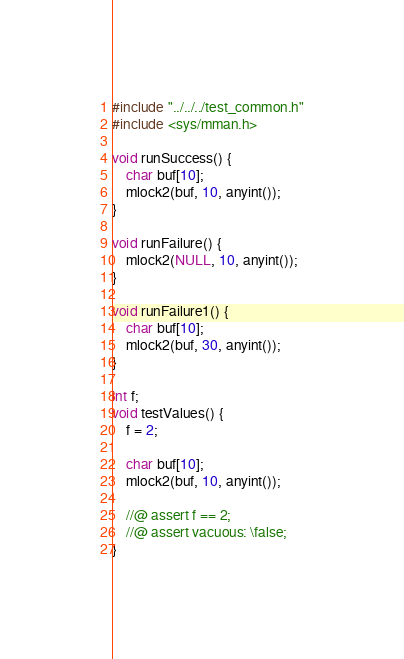Convert code to text. <code><loc_0><loc_0><loc_500><loc_500><_C_>#include "../../../test_common.h"
#include <sys/mman.h>

void runSuccess() {
    char buf[10];
    mlock2(buf, 10, anyint());
}

void runFailure() {
    mlock2(NULL, 10, anyint());
}

void runFailure1() {
    char buf[10];
    mlock2(buf, 30, anyint());
}

int f;
void testValues() {
    f = 2;
    
    char buf[10];
    mlock2(buf, 10, anyint());

    //@ assert f == 2;
    //@ assert vacuous: \false;
}
</code> 